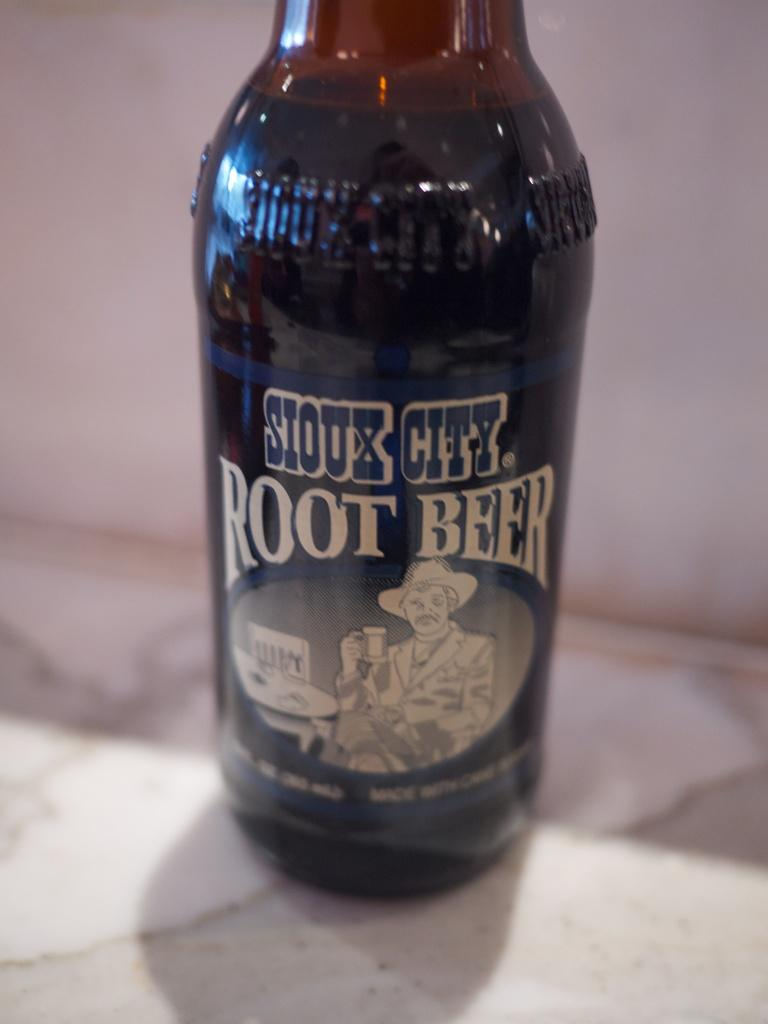<image>
Present a compact description of the photo's key features. Root beer from Sioux City is still sitting on my counter. 